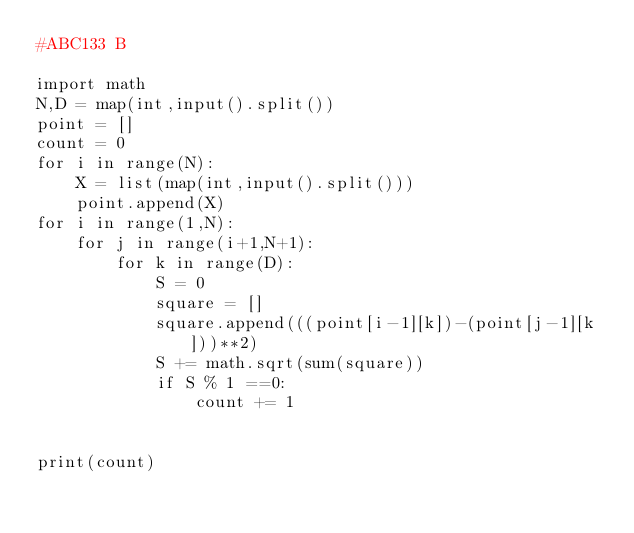Convert code to text. <code><loc_0><loc_0><loc_500><loc_500><_Python_>#ABC133 B

import math
N,D = map(int,input().split())
point = []
count = 0
for i in range(N):
    X = list(map(int,input().split()))
    point.append(X)
for i in range(1,N):
    for j in range(i+1,N+1):
        for k in range(D):
            S = 0
            square = []
            square.append(((point[i-1][k])-(point[j-1][k]))**2)
            S += math.sqrt(sum(square))
            if S % 1 ==0:
                count += 1
        

print(count)</code> 